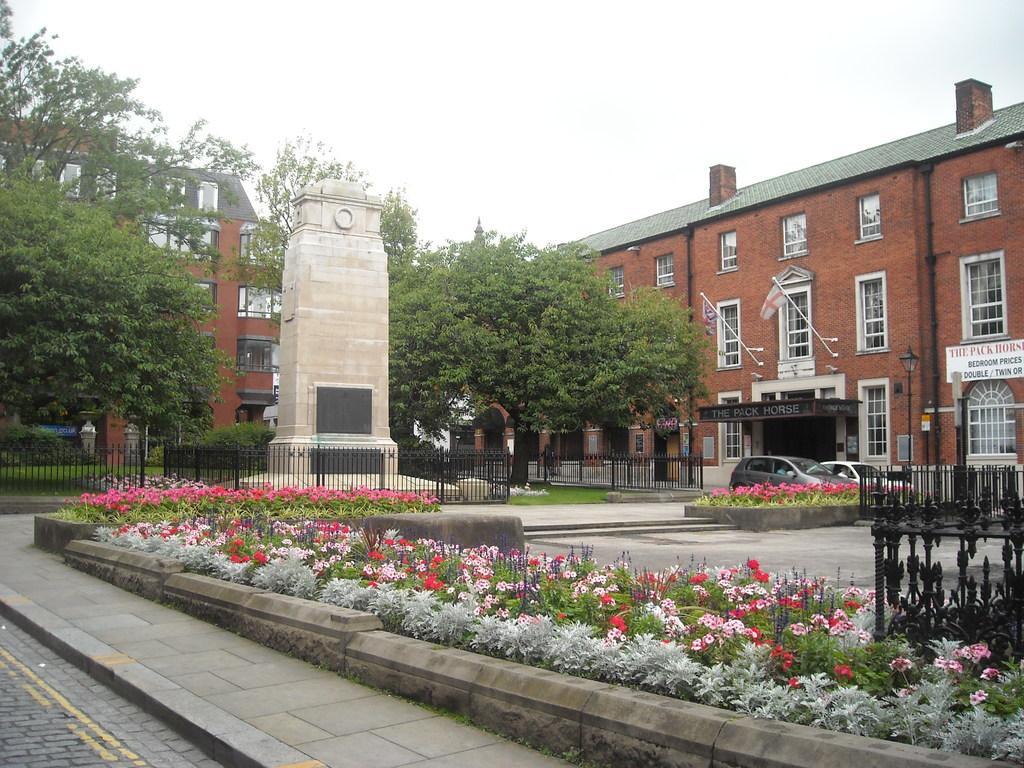Could you give a brief overview of what you see in this image? In this picture we can see plants, trees, fence and other things. Behind the trees there are buildings and a sky. 